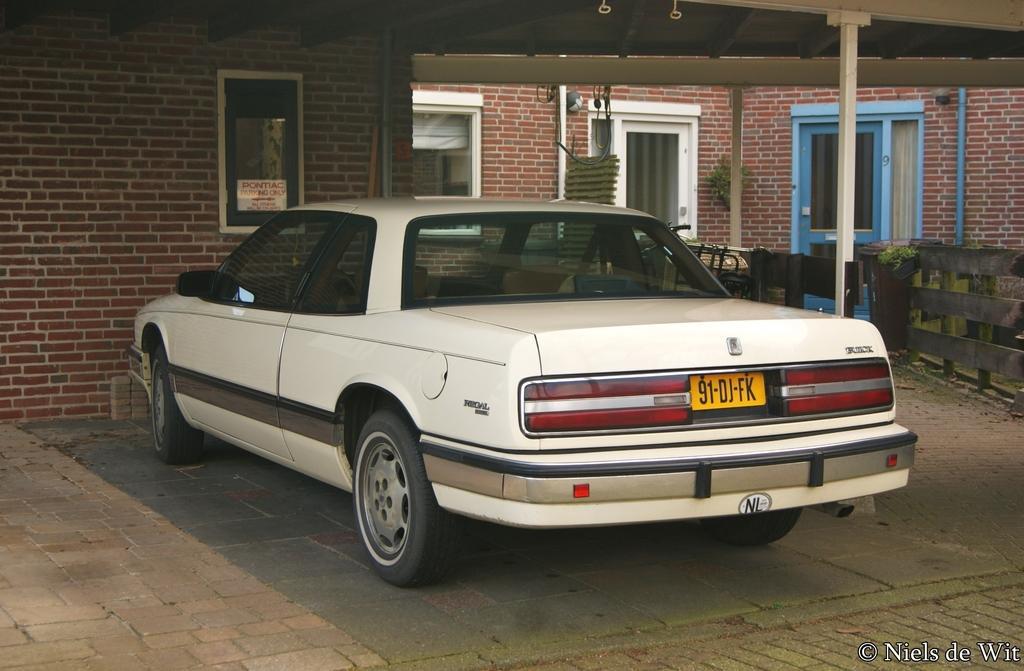How would you summarize this image in a sentence or two? This picture contains white car which is parked beside the building. Beside that, we see a wooden railing. Behind the car, we see a building which is made up of red colored bricks. We even see doors and windows. 